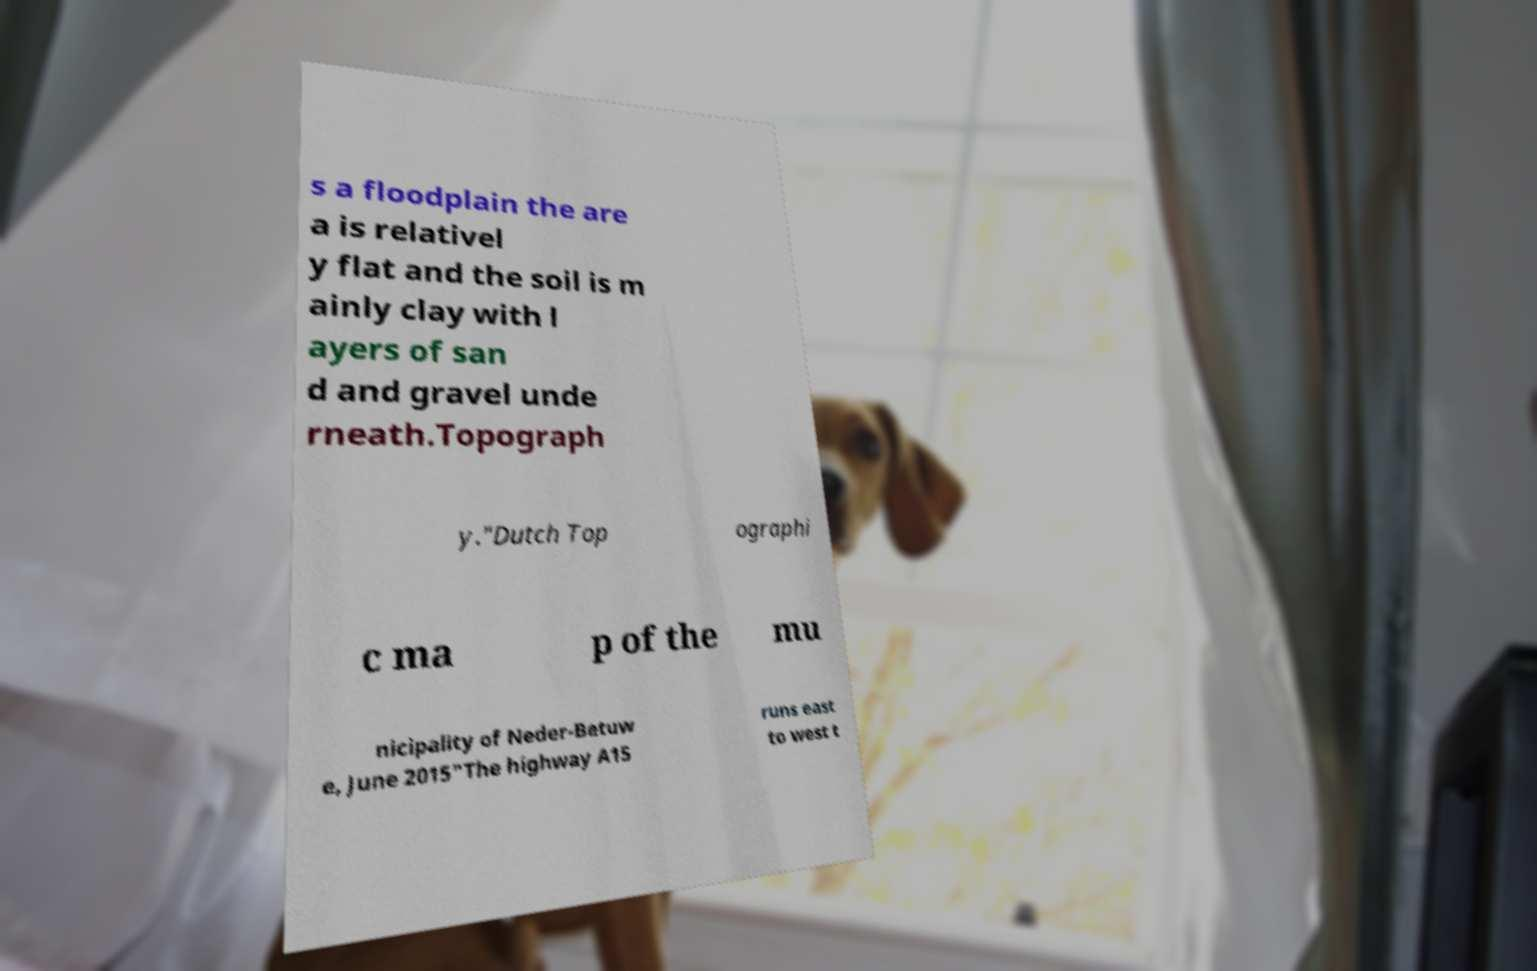What messages or text are displayed in this image? I need them in a readable, typed format. s a floodplain the are a is relativel y flat and the soil is m ainly clay with l ayers of san d and gravel unde rneath.Topograph y."Dutch Top ographi c ma p of the mu nicipality of Neder-Betuw e, June 2015"The highway A15 runs east to west t 